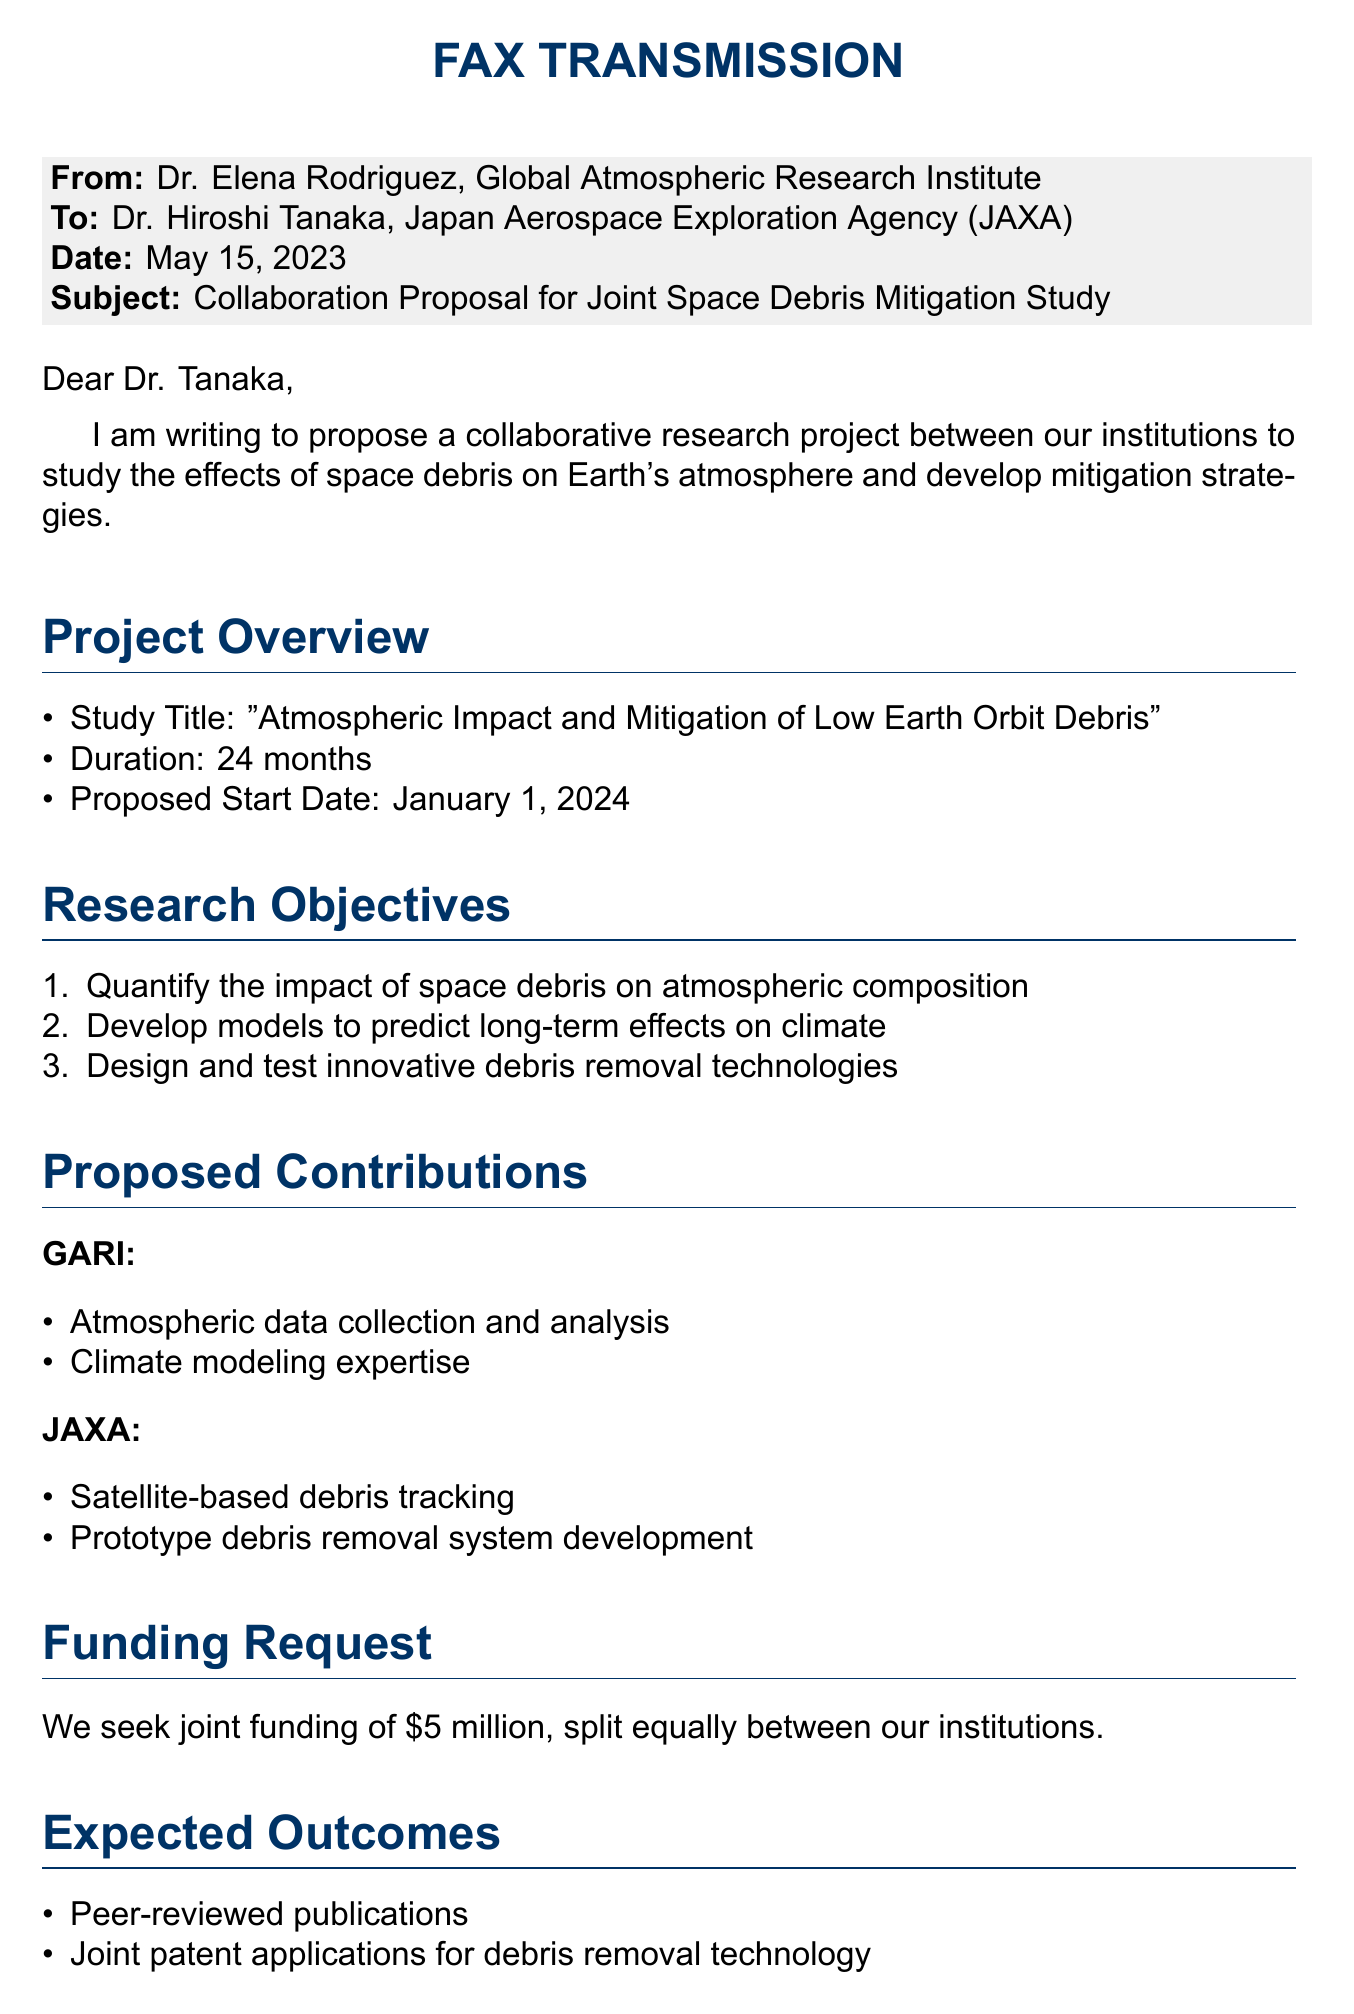What is the name of the proposed project? The document states that the study title is "Atmospheric Impact and Mitigation of Low Earth Orbit Debris."
Answer: "Atmospheric Impact and Mitigation of Low Earth Orbit Debris" Who is the sender of the fax? The sender of the fax is Dr. Elena Rodriguez, as indicated in the document.
Answer: Dr. Elena Rodriguez What is the requested funding amount? The document mentions a joint funding request of $5 million, split equally.
Answer: $5 million What is JAXA's proposed contribution? JAXA is expected to provide satellite-based debris tracking and prototype debris removal system development as contributions.
Answer: Satellite-based debris tracking When is the proposed start date for the project? The document specifies that the proposed start date is January 1, 2024.
Answer: January 1, 2024 How many months will the project last? According to the document, the project duration is 24 months.
Answer: 24 months What outcome is expected from the collaboration? The document outlines that one expected outcome is peer-reviewed publications resulting from the project.
Answer: Peer-reviewed publications Who is the recipient of the fax? The recipient is Dr. Hiroshi Tanaka, as mentioned in the document.
Answer: Dr. Hiroshi Tanaka 